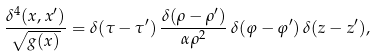<formula> <loc_0><loc_0><loc_500><loc_500>\frac { \delta ^ { 4 } ( x , x ^ { \prime } ) } { \sqrt { g ( x ) } } = \delta ( \tau - \tau ^ { \prime } ) \, \frac { \delta ( \rho - \rho ^ { \prime } ) } { \alpha \rho ^ { 2 } } \, \delta ( \varphi - \varphi ^ { \prime } ) \, \delta ( z - z ^ { \prime } ) ,</formula> 